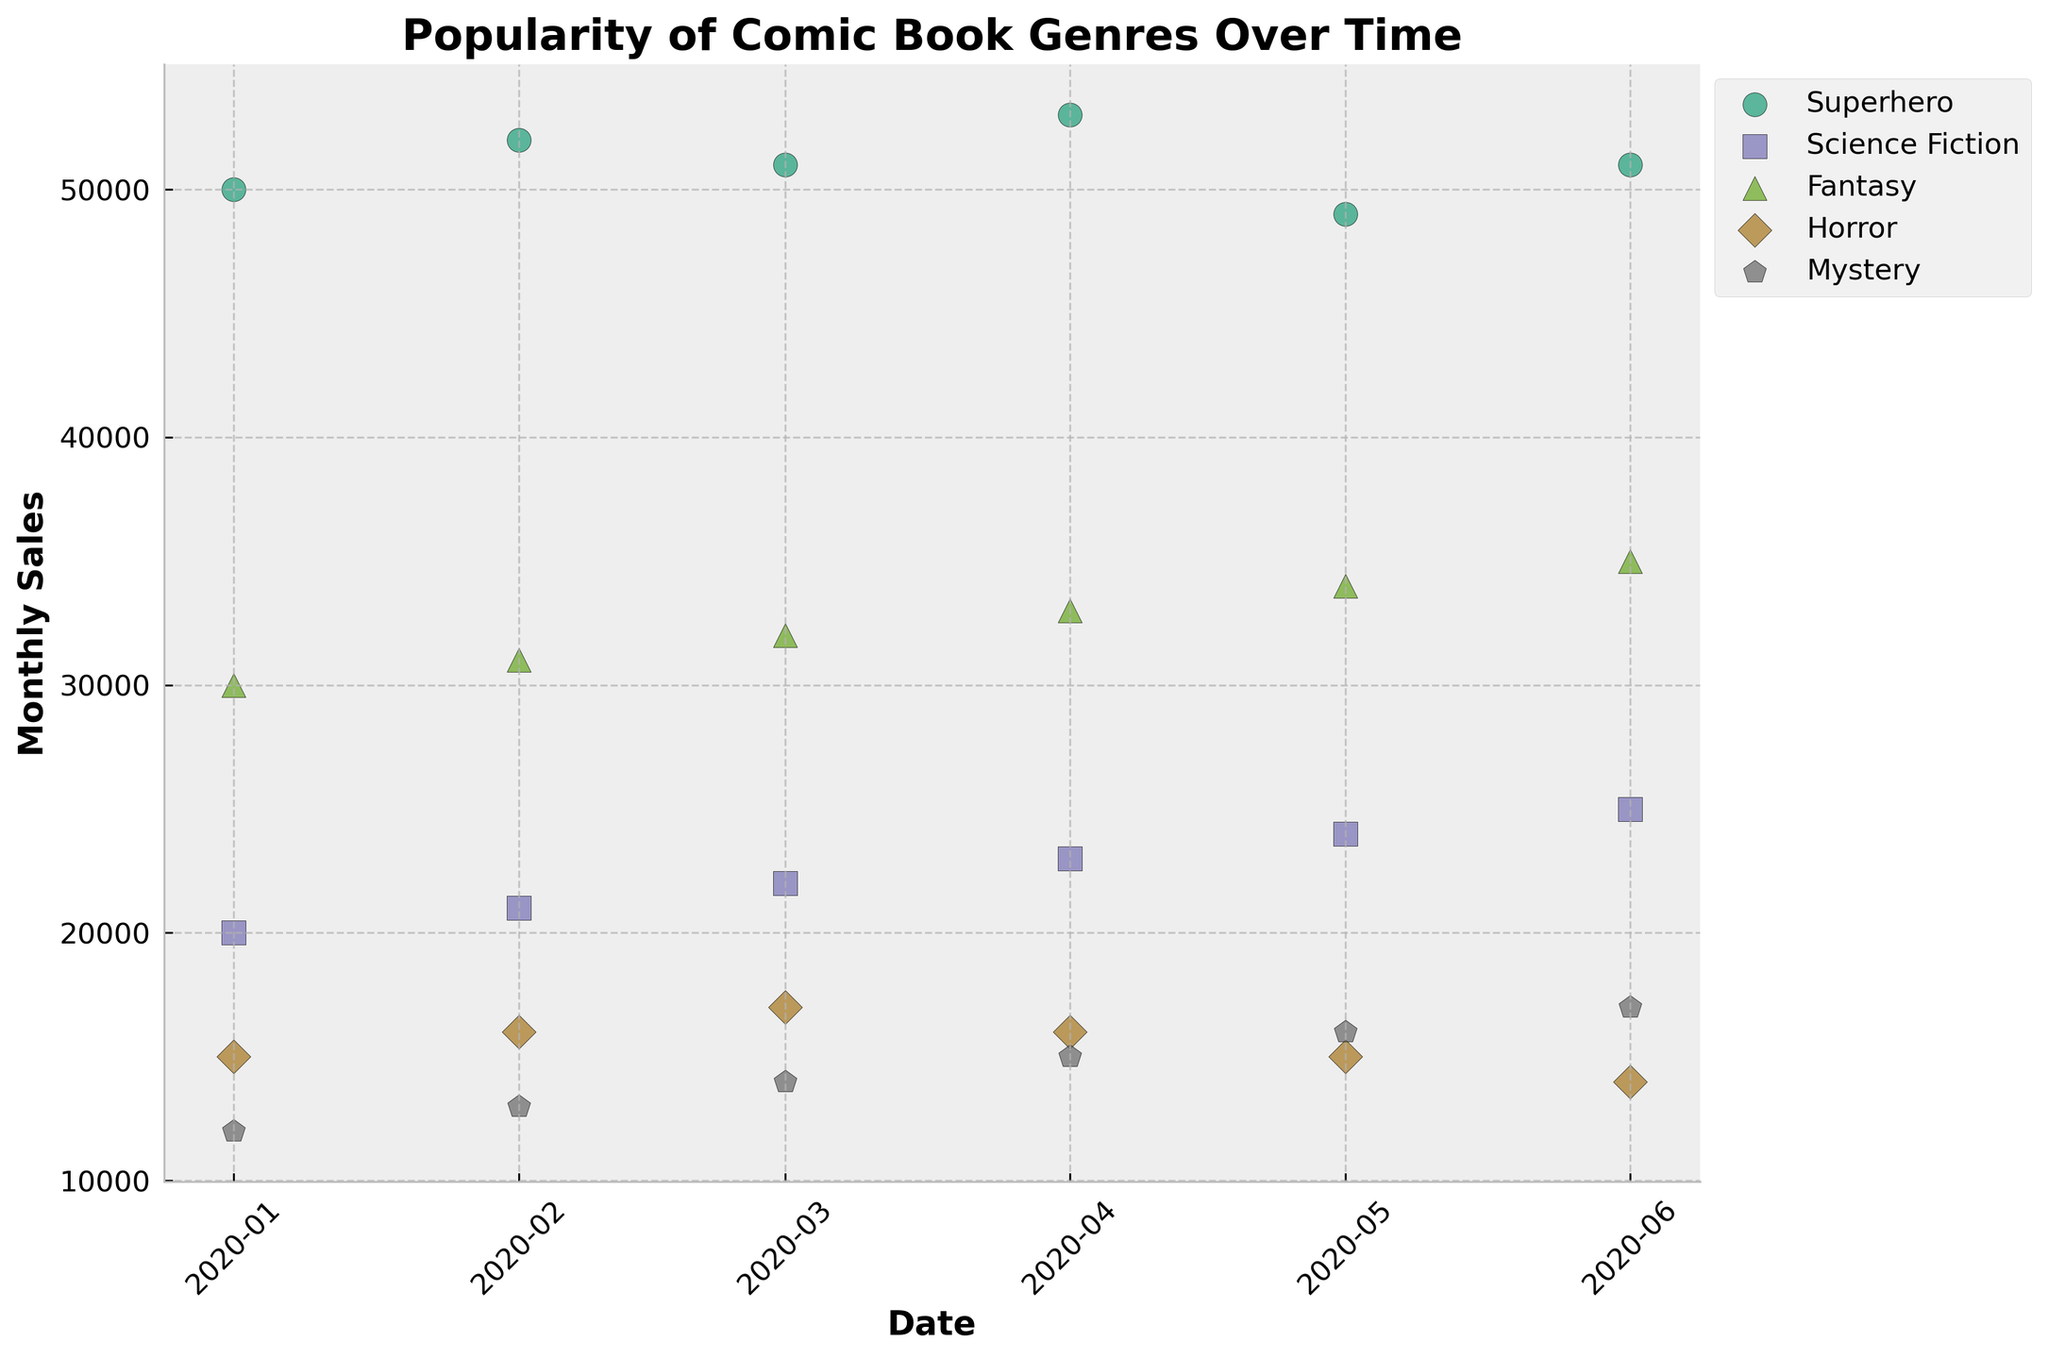Which genre has the highest sales in January 2020? Look at the January 2020 data points for all genres and observe the monthly sales figures. The highest sales in January are for Superhero with 50,000.
Answer: Superhero What is the trend of monthly sales for the Horror genre from January to June 2020? Observe the scatter plot points for the Horror genre from January to June 2020. The sales figures start at 15,000 in January and decrease each month, ending at 14,000 in June.
Answer: Decreasing Compare the average monthly sales of Superhero and Science Fiction genres. Which one has a higher average? For Superhero, the sales figures are 50,000, 52,000, 51,000, 53,000, 49,000, and 51,000. The average is (50,000 + 52,000 + 51,000 + 53,000 + 49,000 + 51,000) / 6 = 51,000. For Science Fiction, the sales figures are 20,000, 21,000, 22,000, 23,000, 24,000, and 25,000. The average is (20,000 + 21,000 + 22,000 + 23,000 + 24,000 + 25,000) / 6 = 22,500. Hence, Superhero has a higher average.
Answer: Superhero Which genre experienced a decrease in monthly sales from March to April 2020? Look at the scatter plot points for each genre between March and April 2020. Only Horror shows a decrease from 17,000 in March to 16,000 in April.
Answer: Horror Is there a particular month where all genres saw an increase in sales compared to the previous month? Examine the plot for each genre, checking if sales went up from one month to the next for all genres simultaneously. This check should occur from February to March, March to April, April to May, and May to June for all genres.
Answer: No What is the general trend in monthly sales for the Fantasy genre from January to June 2020? Observe the scatter plot points for the Fantasy genre from January to June 2020. The trend is consistently increasing, starting at 30,000 in January and rising to 35,000 in June.
Answer: Increasing Between January and February 2020, which genre saw the largest increase in monthly sales? Calculate the difference in sales between January and February for all genres. Superhero: 52,000 - 50,000 = 2,000; Science Fiction: 21,000 - 20,000 = 1,000; Fantasy: 31,000 - 30,000 = 1,000; Horror: 16,000 - 15,000 = 1,000; Mystery: 13,000 - 12,000 = 1,000. The Superhero genre had the largest increase.
Answer: Superhero What is the difference in monthly sales for Superhero from January to May 2020? Calculate the difference in sales for Superhero from January (50,000) to May (49,000). The difference is 50,000 - 49,000 = 1,000.
Answer: 1,000 Which genre has consistently increasing monthly sales over the six months? Examine the scatter plot for each genre to find any that have continuously increasing sales points. Fantasy has increasing sales from January (30,000) to June (35,000).
Answer: Fantasy 